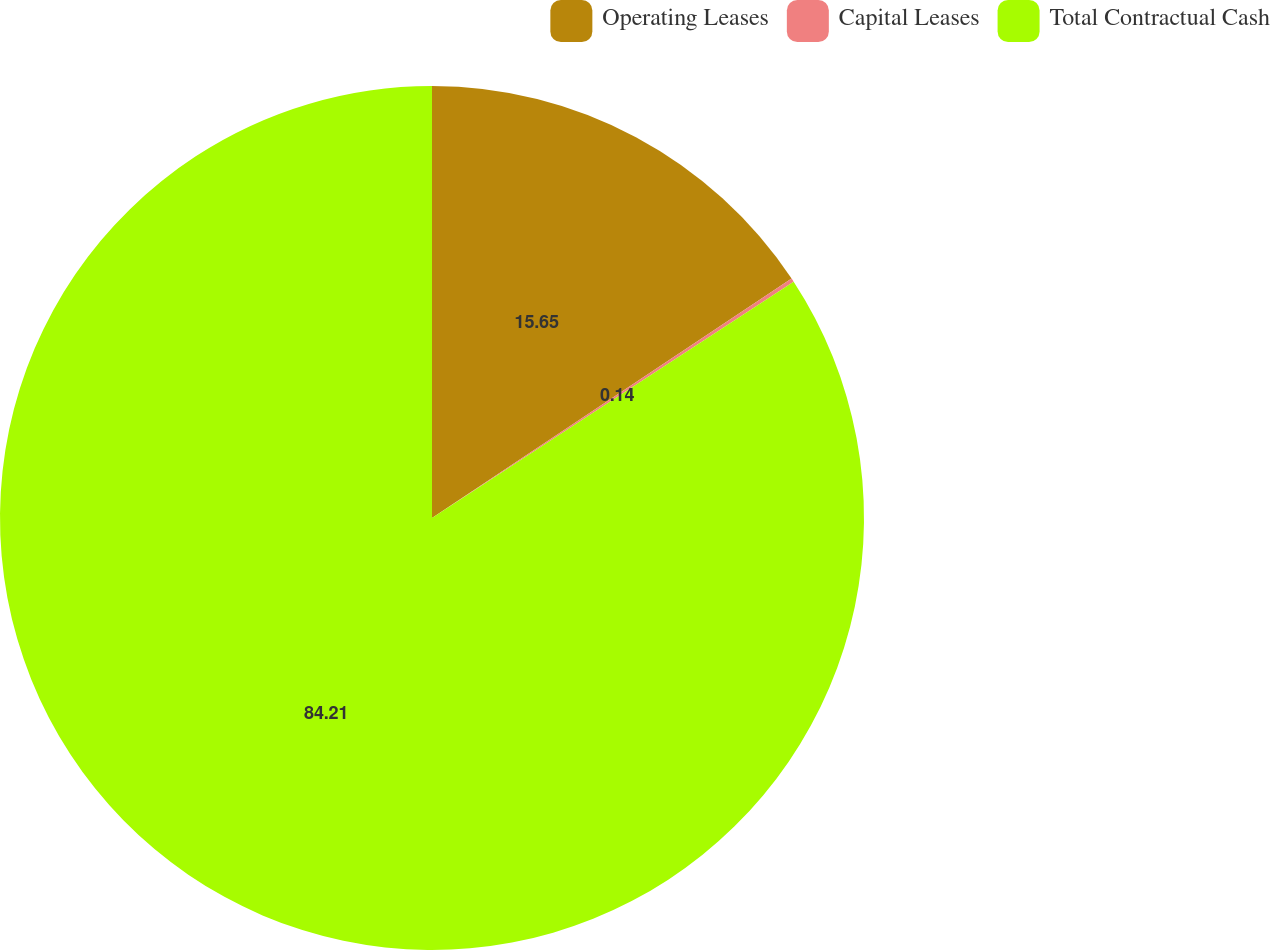<chart> <loc_0><loc_0><loc_500><loc_500><pie_chart><fcel>Operating Leases<fcel>Capital Leases<fcel>Total Contractual Cash<nl><fcel>15.65%<fcel>0.14%<fcel>84.21%<nl></chart> 